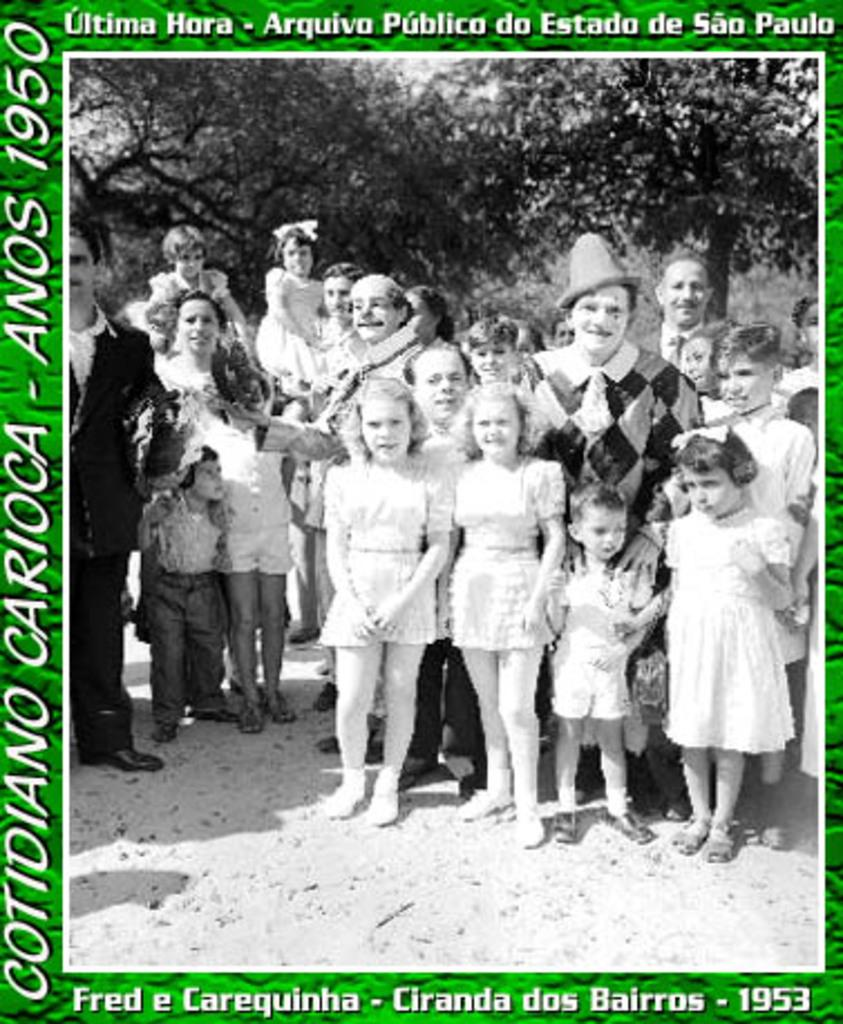What is featured on the poster in the image? The poster contains a group of people. What else can be seen in the image besides the poster? There are trees visible in the image. Is there any text on the poster? Yes, there is text written on the poster. Can you tell me how many goldfish are swimming in the poster? There are no goldfish present in the image or on the poster. What type of sail is featured on the poster? There is no sail present in the image or on the poster. 